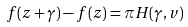Convert formula to latex. <formula><loc_0><loc_0><loc_500><loc_500>f ( z + \gamma ) - f ( z ) = \pi H ( \gamma , v )</formula> 